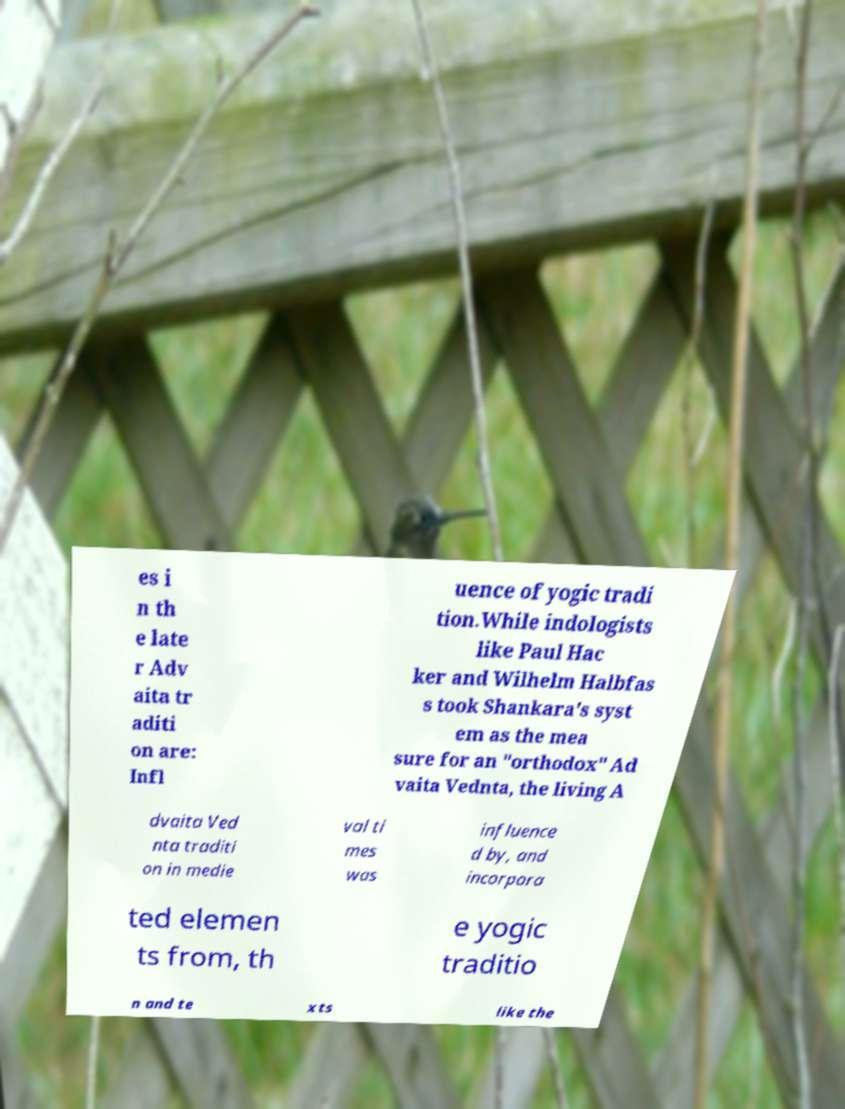Could you extract and type out the text from this image? es i n th e late r Adv aita tr aditi on are: Infl uence of yogic tradi tion.While indologists like Paul Hac ker and Wilhelm Halbfas s took Shankara's syst em as the mea sure for an "orthodox" Ad vaita Vednta, the living A dvaita Ved nta traditi on in medie val ti mes was influence d by, and incorpora ted elemen ts from, th e yogic traditio n and te xts like the 